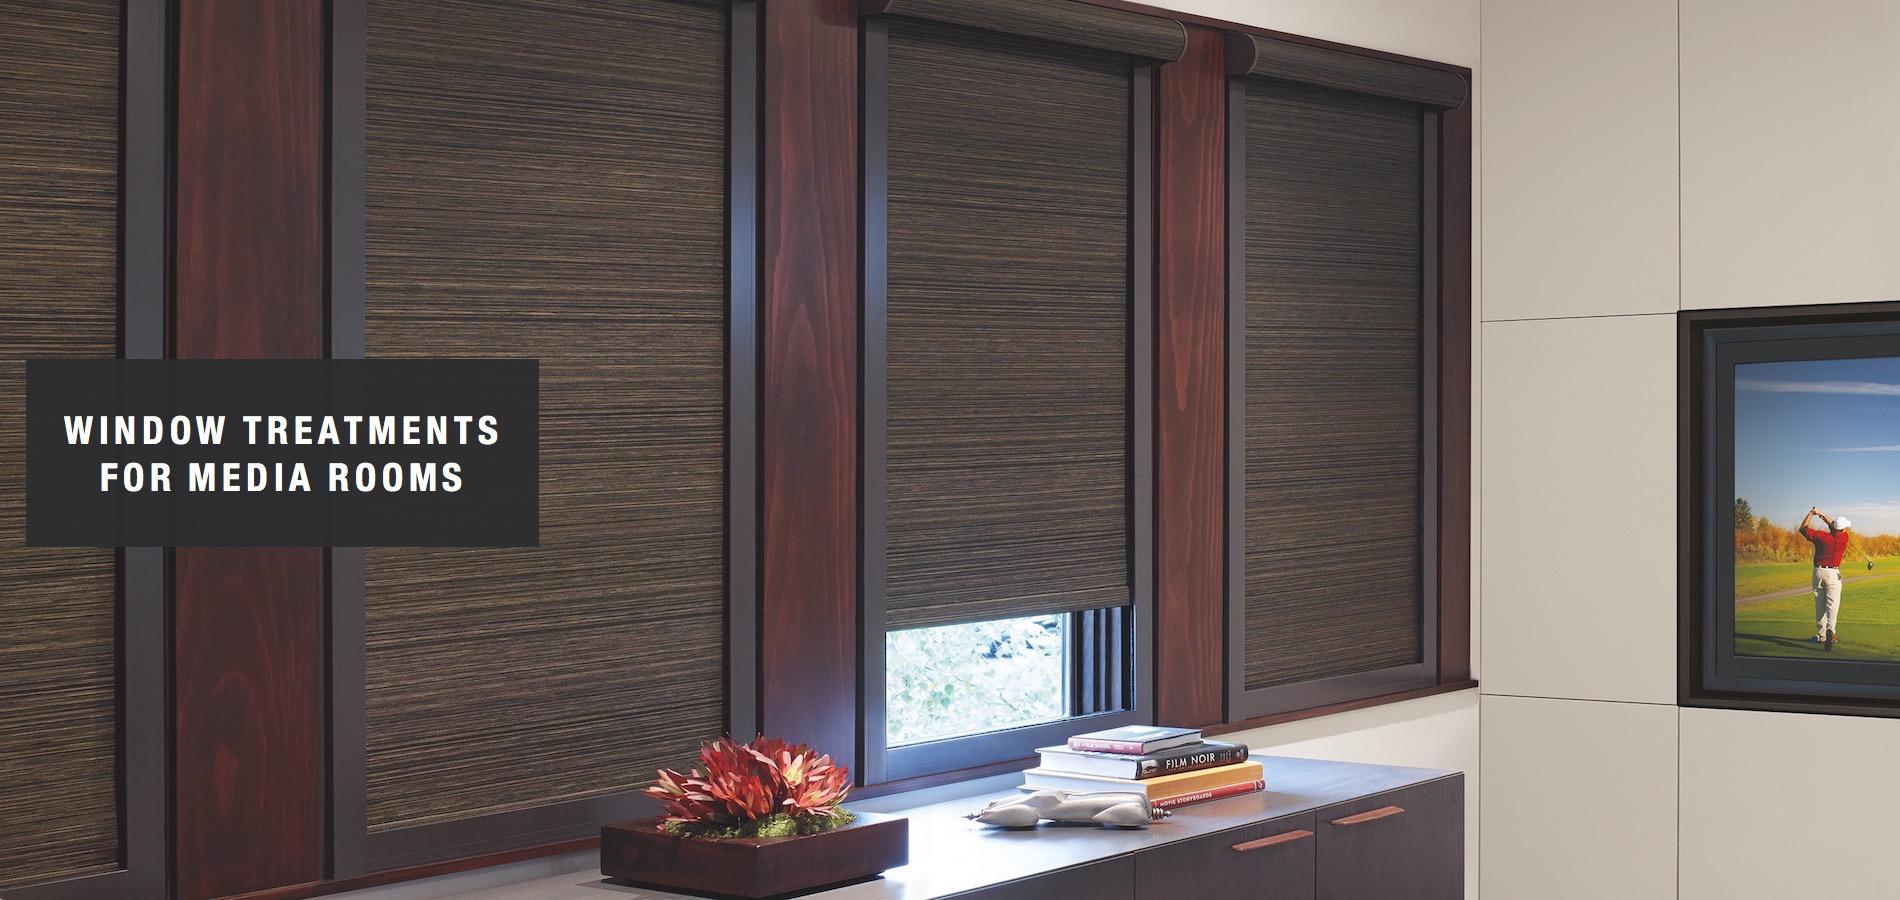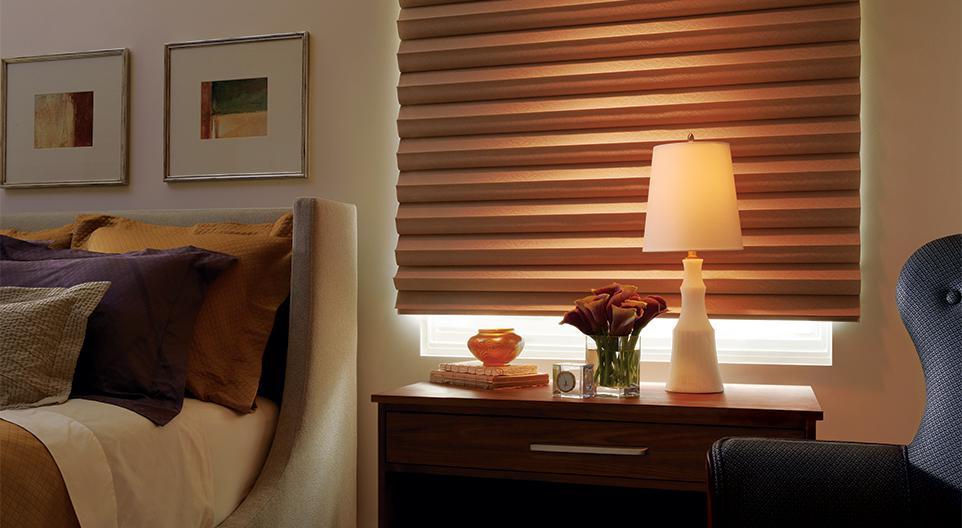The first image is the image on the left, the second image is the image on the right. Examine the images to the left and right. Is the description "The left and right image contains a total of five blinds." accurate? Answer yes or no. Yes. The first image is the image on the left, the second image is the image on the right. For the images displayed, is the sentence "In the image to the left, the slats of the window shade are not completely closed; you can still see a little bit of light." factually correct? Answer yes or no. No. 